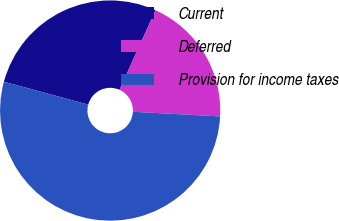<chart> <loc_0><loc_0><loc_500><loc_500><pie_chart><fcel>Current<fcel>Deferred<fcel>Provision for income taxes<nl><fcel>27.54%<fcel>19.09%<fcel>53.37%<nl></chart> 